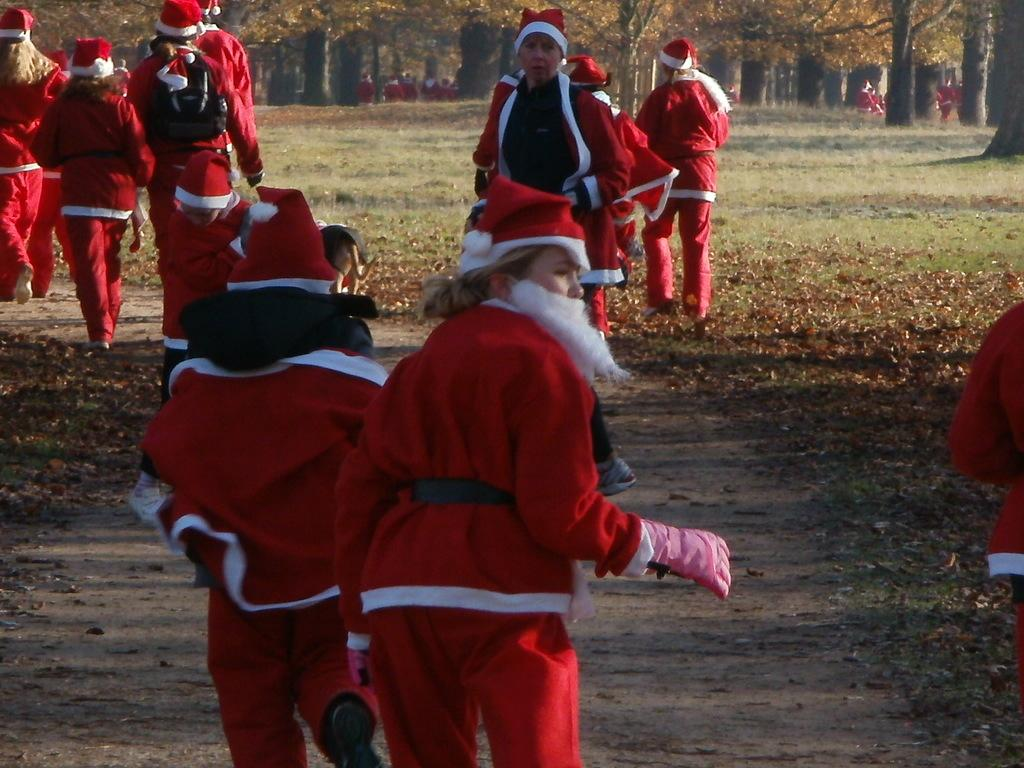What are the people in the image wearing? The people in the image are wearing costumes. What type of vegetation can be seen in the image? Leaves and grass are visible in the image. Can you describe the background of the image? There are people and trees in the background of the image. What type of button can be seen on the costume of the person in the image? There is no button visible on the costumes of the people in the image. Can you describe the argument between the people in the image? There is no argument depicted in the image; the people are wearing costumes and there is no indication of any conflict. 